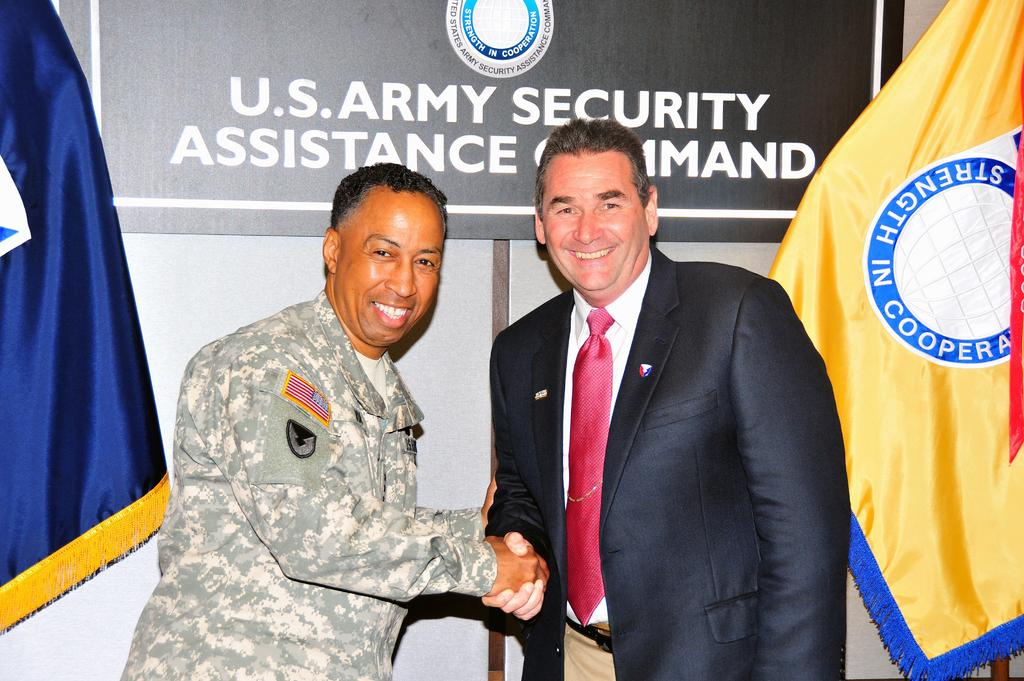How many people are in the image? There are two men in the image. Where are the men located in the image? The men are standing in the center of the image. What is the surface they are standing on? The men are standing on the floor. What can be seen in the background of the image? There is a board and flags in the background of the image. Can you see the bone that the dog is holding in the image? There is no dog or bone present in the image. 